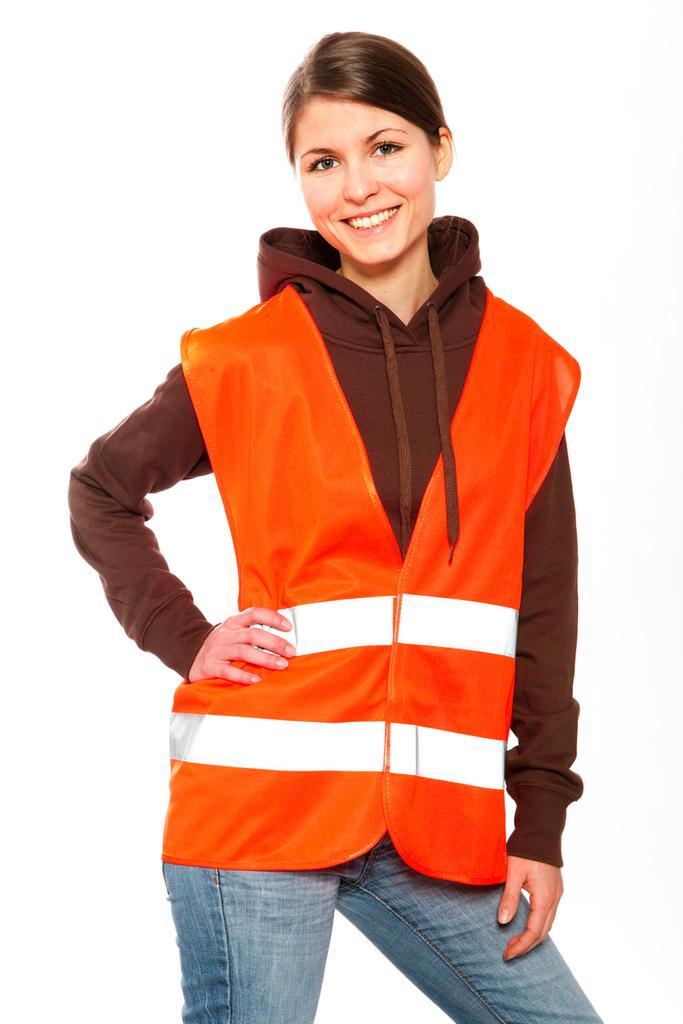Could you give a brief overview of what you see in this image? In this image we can see a woman is standing and smiling. In the background the image is white in color. 